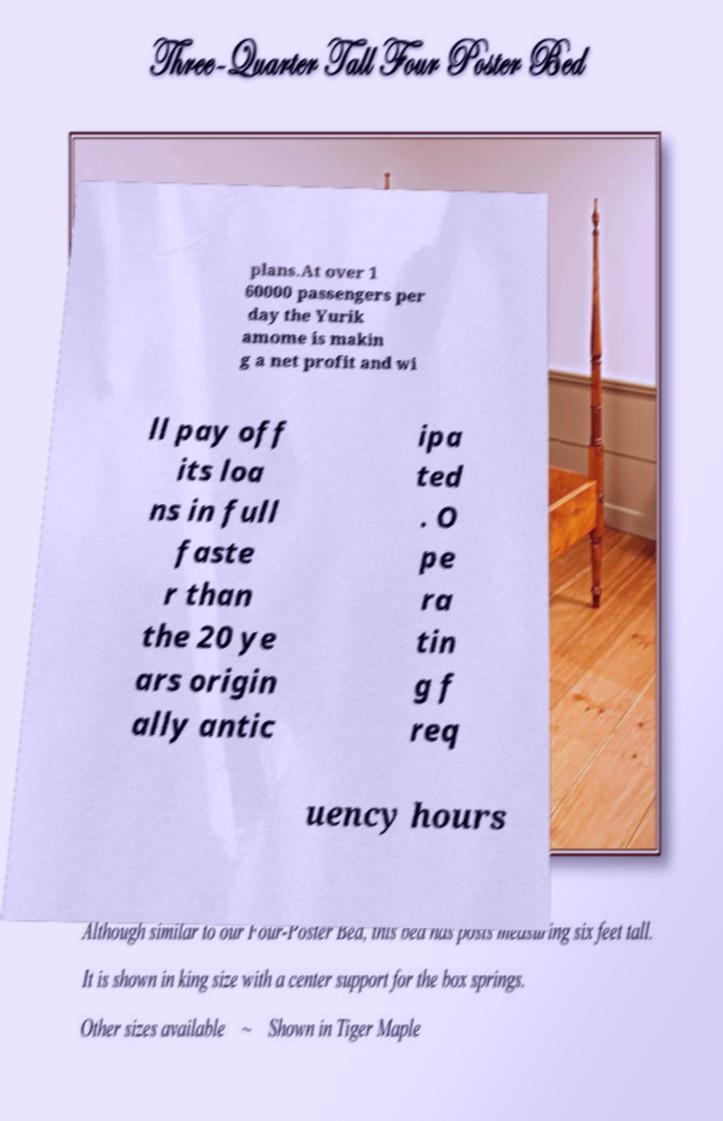Can you read and provide the text displayed in the image?This photo seems to have some interesting text. Can you extract and type it out for me? plans.At over 1 60000 passengers per day the Yurik amome is makin g a net profit and wi ll pay off its loa ns in full faste r than the 20 ye ars origin ally antic ipa ted . O pe ra tin g f req uency hours 